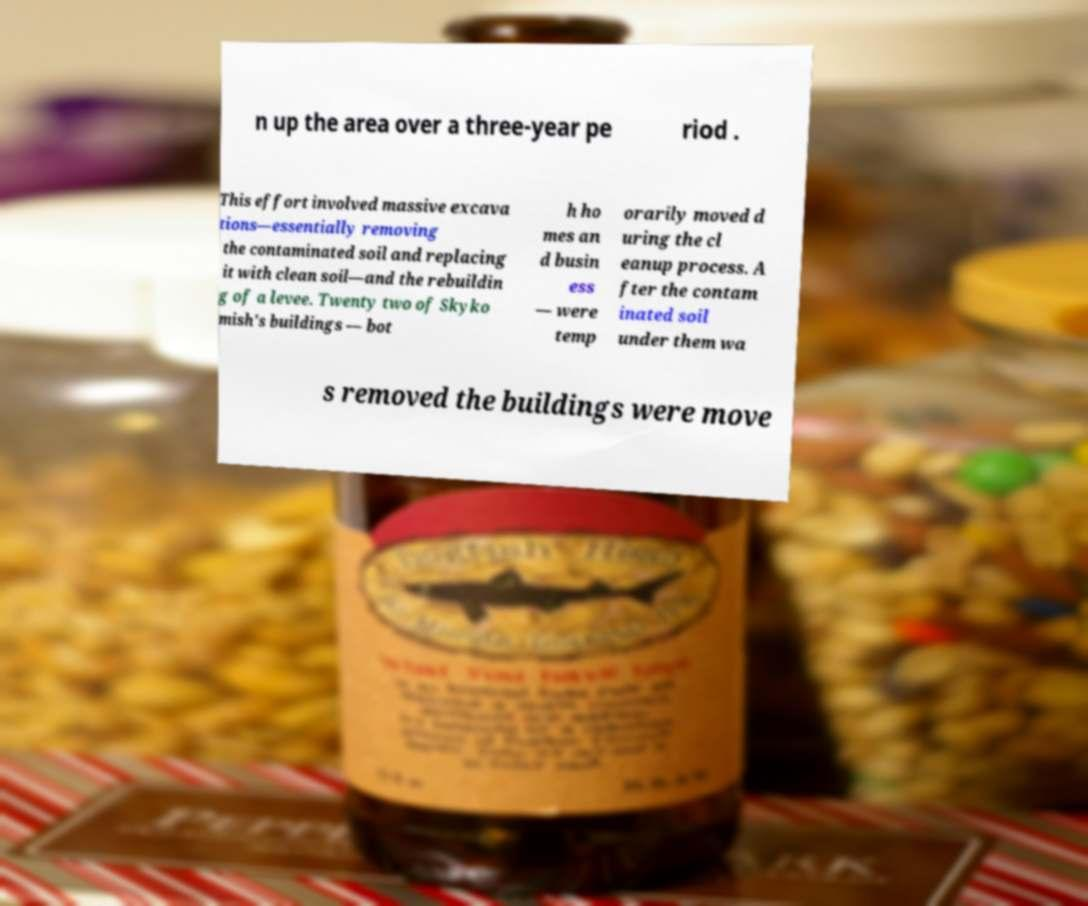There's text embedded in this image that I need extracted. Can you transcribe it verbatim? n up the area over a three-year pe riod . This effort involved massive excava tions—essentially removing the contaminated soil and replacing it with clean soil—and the rebuildin g of a levee. Twenty two of Skyko mish's buildings — bot h ho mes an d busin ess — were temp orarily moved d uring the cl eanup process. A fter the contam inated soil under them wa s removed the buildings were move 